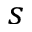Convert formula to latex. <formula><loc_0><loc_0><loc_500><loc_500>s</formula> 